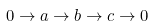Convert formula to latex. <formula><loc_0><loc_0><loc_500><loc_500>0 \to a \to b \to c \to 0</formula> 